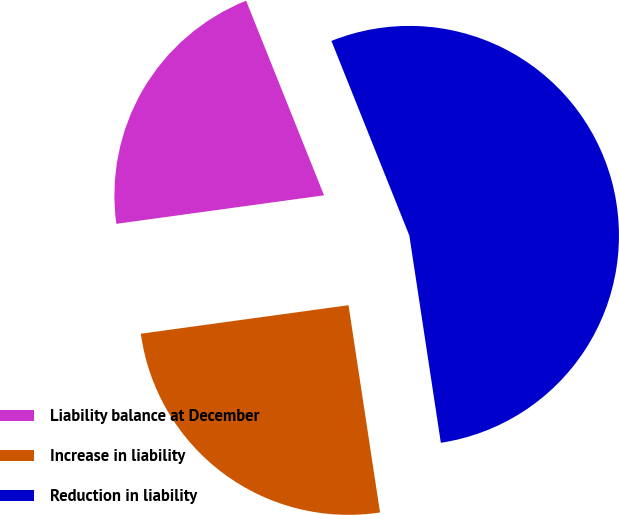Convert chart to OTSL. <chart><loc_0><loc_0><loc_500><loc_500><pie_chart><fcel>Liability balance at December<fcel>Increase in liability<fcel>Reduction in liability<nl><fcel>21.11%<fcel>25.23%<fcel>53.66%<nl></chart> 